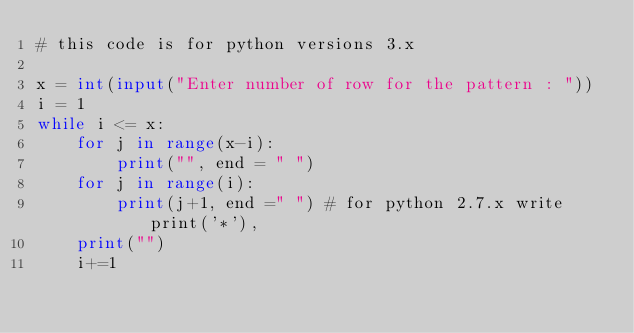Convert code to text. <code><loc_0><loc_0><loc_500><loc_500><_Python_># this code is for python versions 3.x

x = int(input("Enter number of row for the pattern : "))
i = 1
while i <= x:
    for j in range(x-i):
        print("", end = " ")
    for j in range(i):
        print(j+1, end =" ") # for python 2.7.x write print('*'),
    print("")
    i+=1
</code> 